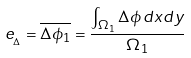<formula> <loc_0><loc_0><loc_500><loc_500>e _ { _ { \Delta } } = \overline { \Delta \phi _ { 1 } } = \frac { \int _ { \Omega _ { 1 } } \Delta \phi \, d x d y } { \Omega _ { 1 } }</formula> 